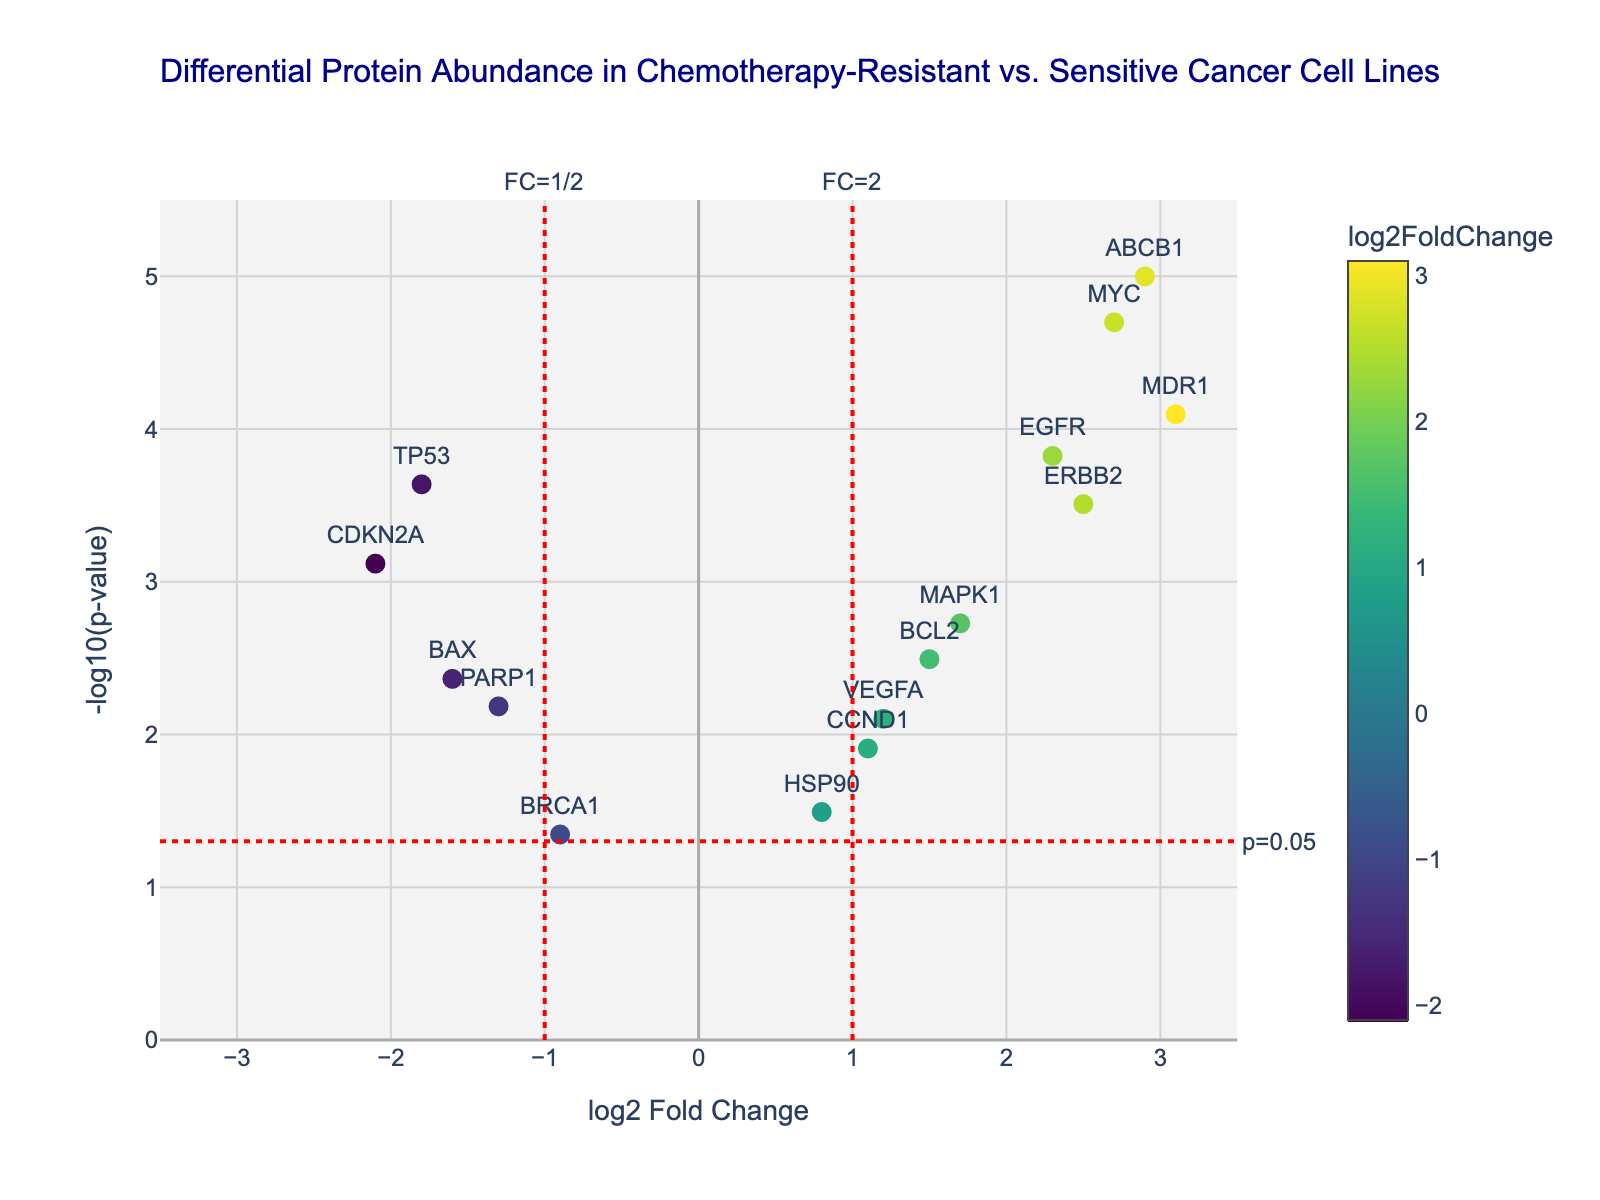Which protein has the highest log2 fold change? To answer this question, look for the protein with the maximum value along the x-axis (log2 Fold Change). The highest value is for MDR1 with a log2 fold change of 3.1.
Answer: MDR1 Which protein has the lowest p-value? To find the protein with the lowest p-value, look for the data point that is highest on the y-axis (-log10(p-value)). This protein is ABCB1 with a p-value of 0.00001.
Answer: ABCB1 What is the log2 fold change and p-value of the TP53 protein? Look for the TP53 label in the plot. According to the data, it has a log2 fold change of -1.8 and a p-value of 0.00023.
Answer: -1.8, 0.00023 Which proteins are more abundant in chemotherapy-resistant cells compared to sensitive cells? Proteins with positive log2 fold changes are more abundant in resistant cells. These proteins are EGFR, MDR1, BCL2, VEGFA, MYC, MAPK1, ABCB1, CCND1, and ERBB2.
Answer: EGFR, MDR1, BCL2, VEGFA, MYC, MAPK1, ABCB1, CCND1, ERBB2 How many proteins have a log2 fold change greater than 2? Look for the proteins with log2 fold change values greater than 2. These are EGFR, MDR1, MYC, ABCB1, and ERBB2. Total is 5.
Answer: 5 Which protein is closest to the threshold line for p-value significance (p = 0.05)? Look for the protein whose -log10(p-value) is closest to the horizontal red dashed line, which represents p = 0.05 (approximately -log10(0.05) ≈ 1.3). The closest one is BRCA1.
Answer: BRCA1 Between EGFR and PARP1, which protein shows more significant differential abundance (in terms of p-value)? Compare the -log10(p-value) for both proteins. EGFR has a value of -log10(0.00015), and PARP1 has a value of -log10(0.00654). The higher -log10(p-value) indicates a more significant result. EGFR's -log10(p-value) is higher, making it more significant.
Answer: EGFR What is the range of p-values shown in the plot? To find the range, identify the smallest and largest p-values from the data. The smallest p-value is 0.00001 (ABCB1) and the largest is 0.04512 (BRCA1). Therefore, the range is from 0.00001 to 0.04512.
Answer: 0.00001 to 0.04512 